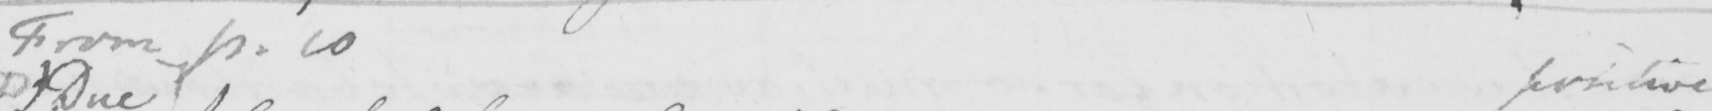Can you tell me what this handwritten text says? From p . 10 positive 